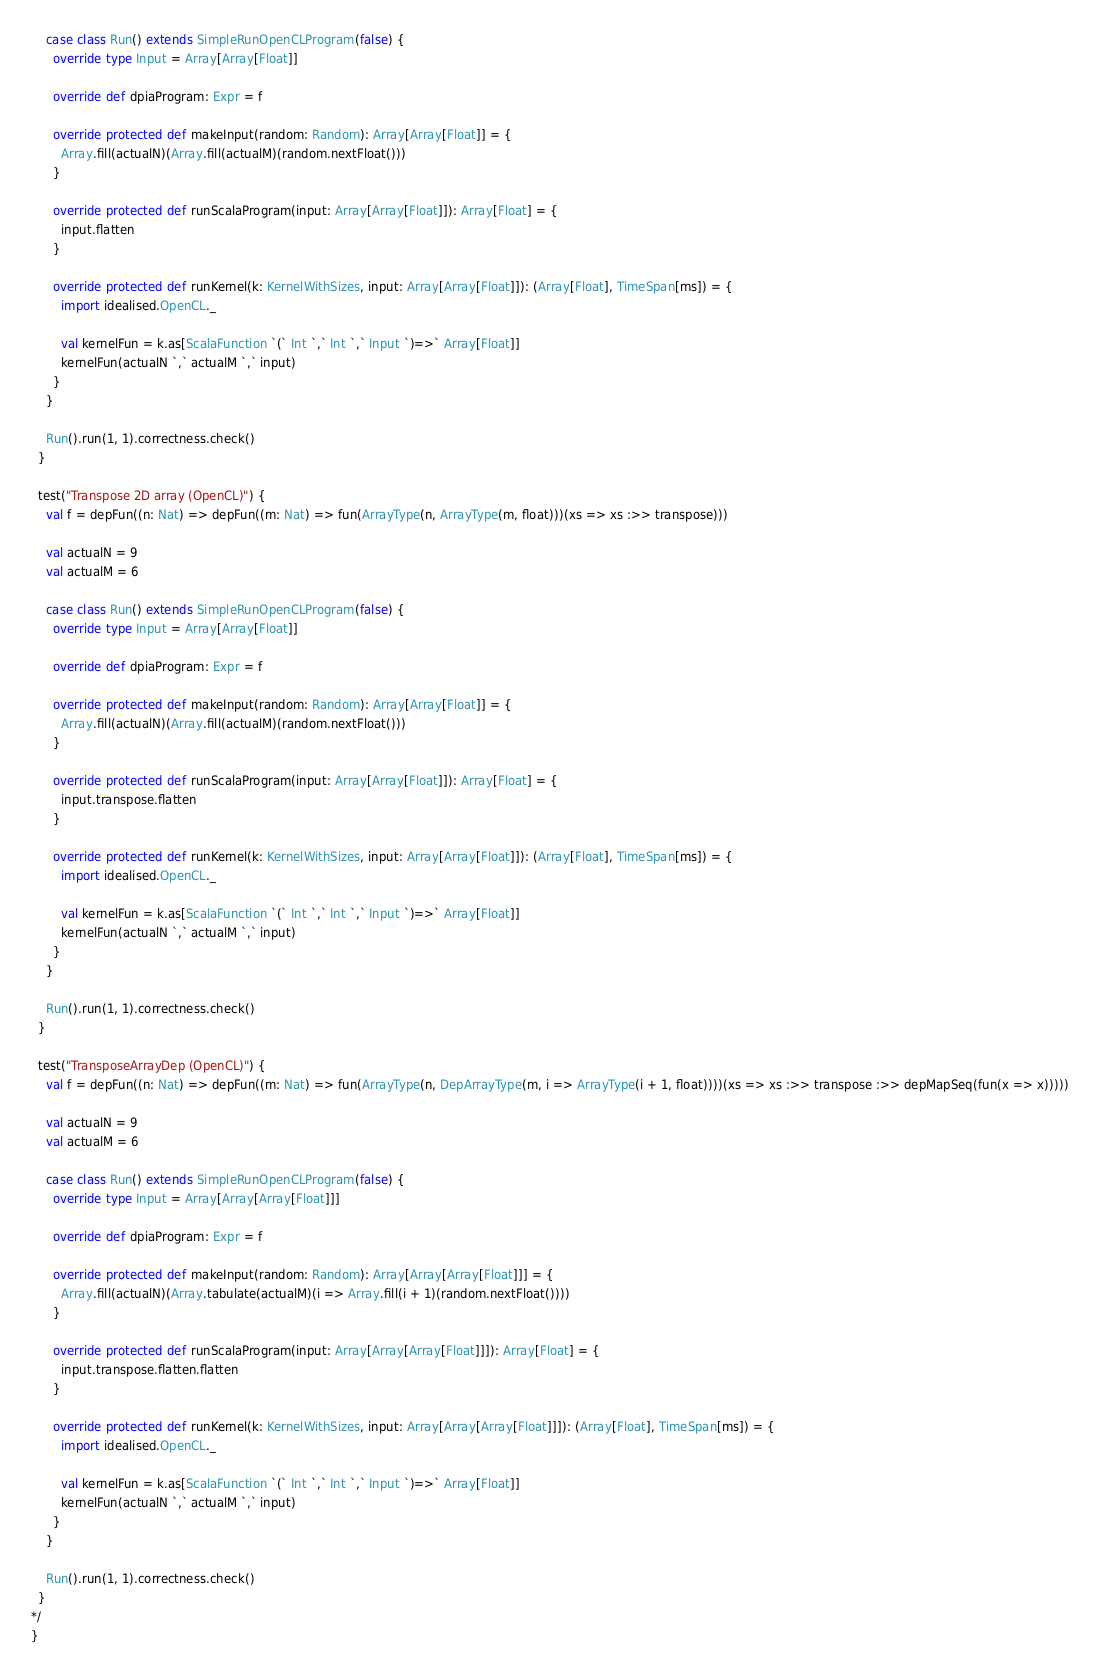Convert code to text. <code><loc_0><loc_0><loc_500><loc_500><_Scala_>    case class Run() extends SimpleRunOpenCLProgram(false) {
      override type Input = Array[Array[Float]]

      override def dpiaProgram: Expr = f

      override protected def makeInput(random: Random): Array[Array[Float]] = {
        Array.fill(actualN)(Array.fill(actualM)(random.nextFloat()))
      }

      override protected def runScalaProgram(input: Array[Array[Float]]): Array[Float] = {
        input.flatten
      }

      override protected def runKernel(k: KernelWithSizes, input: Array[Array[Float]]): (Array[Float], TimeSpan[ms]) = {
        import idealised.OpenCL._

        val kernelFun = k.as[ScalaFunction `(` Int `,` Int `,` Input `)=>` Array[Float]]
        kernelFun(actualN `,` actualM `,` input)
      }
    }

    Run().run(1, 1).correctness.check()
  }

  test("Transpose 2D array (OpenCL)") {
    val f = depFun((n: Nat) => depFun((m: Nat) => fun(ArrayType(n, ArrayType(m, float)))(xs => xs :>> transpose)))

    val actualN = 9
    val actualM = 6

    case class Run() extends SimpleRunOpenCLProgram(false) {
      override type Input = Array[Array[Float]]

      override def dpiaProgram: Expr = f

      override protected def makeInput(random: Random): Array[Array[Float]] = {
        Array.fill(actualN)(Array.fill(actualM)(random.nextFloat()))
      }

      override protected def runScalaProgram(input: Array[Array[Float]]): Array[Float] = {
        input.transpose.flatten
      }

      override protected def runKernel(k: KernelWithSizes, input: Array[Array[Float]]): (Array[Float], TimeSpan[ms]) = {
        import idealised.OpenCL._

        val kernelFun = k.as[ScalaFunction `(` Int `,` Int `,` Input `)=>` Array[Float]]
        kernelFun(actualN `,` actualM `,` input)
      }
    }

    Run().run(1, 1).correctness.check()
  }

  test("TransposeArrayDep (OpenCL)") {
    val f = depFun((n: Nat) => depFun((m: Nat) => fun(ArrayType(n, DepArrayType(m, i => ArrayType(i + 1, float))))(xs => xs :>> transpose :>> depMapSeq(fun(x => x)))))

    val actualN = 9
    val actualM = 6

    case class Run() extends SimpleRunOpenCLProgram(false) {
      override type Input = Array[Array[Array[Float]]]

      override def dpiaProgram: Expr = f

      override protected def makeInput(random: Random): Array[Array[Array[Float]]] = {
        Array.fill(actualN)(Array.tabulate(actualM)(i => Array.fill(i + 1)(random.nextFloat())))
      }

      override protected def runScalaProgram(input: Array[Array[Array[Float]]]): Array[Float] = {
        input.transpose.flatten.flatten
      }

      override protected def runKernel(k: KernelWithSizes, input: Array[Array[Array[Float]]]): (Array[Float], TimeSpan[ms]) = {
        import idealised.OpenCL._

        val kernelFun = k.as[ScalaFunction `(` Int `,` Int `,` Input `)=>` Array[Float]]
        kernelFun(actualN `,` actualM `,` input)
      }
    }

    Run().run(1, 1).correctness.check()
  }
*/
}
</code> 